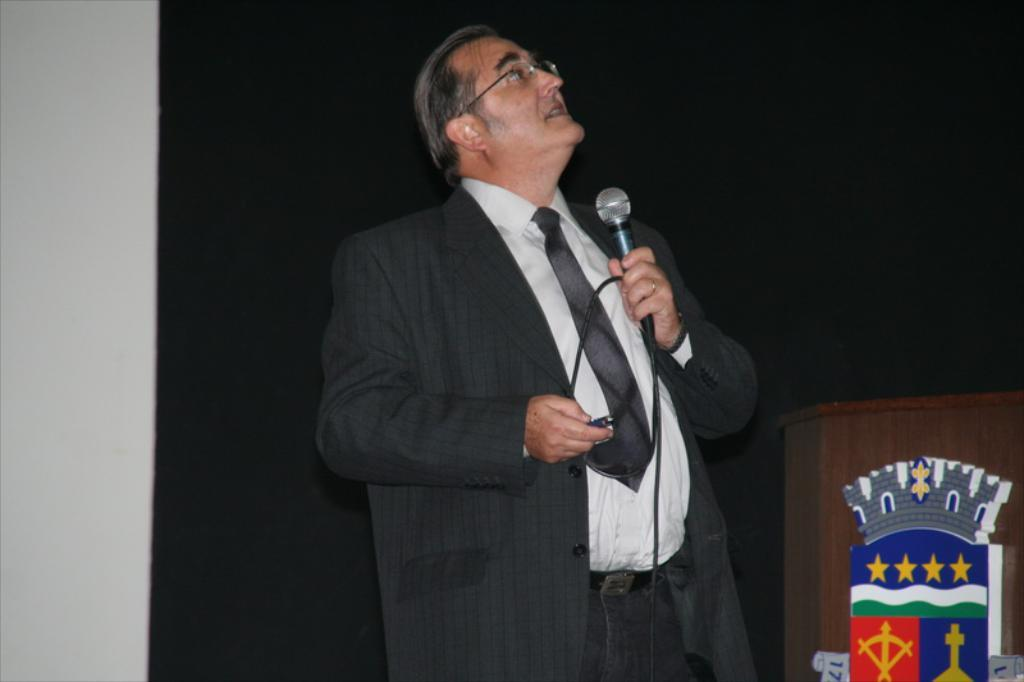What is the man in the image wearing? The man is wearing a blazer, a tie, and spectacles. What is the man holding in one hand? The man is holding a microphone in one hand. What is the man holding in the other hand? The man is holding a remote in the other hand. What is located beside the man? There is a podium beside the man. What is the color of the background in the image? The background of the image is dark. What letter is the man holding in the image? There is no letter present in the image; the man is holding a microphone and a remote. What type of knowledge is the man sharing in the image? The image does not provide information about the content of the man's speech or the knowledge he is sharing. 